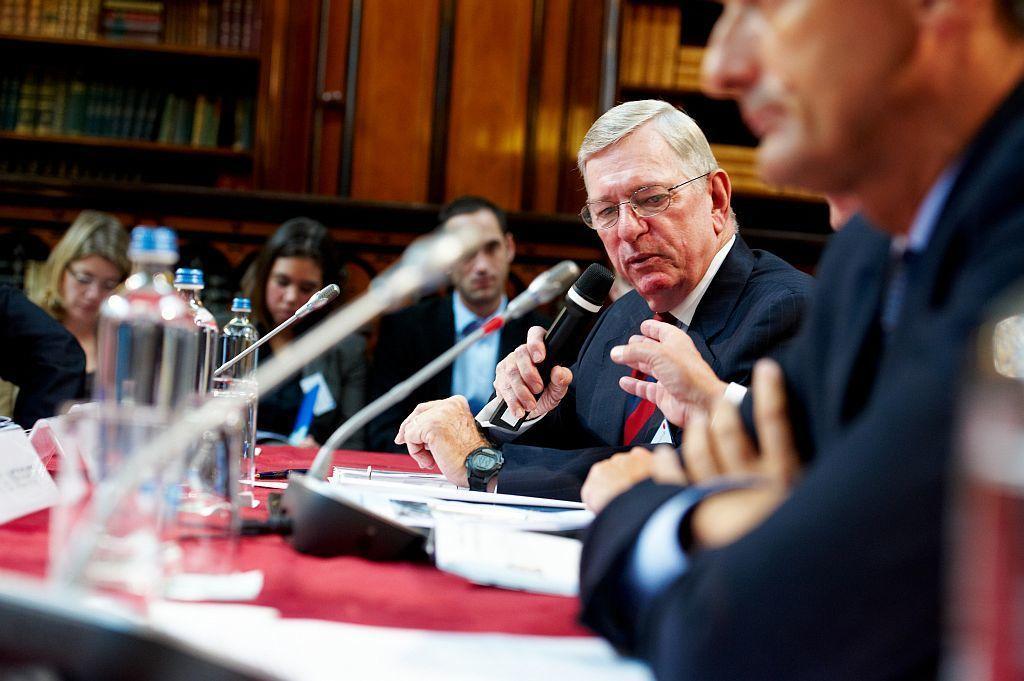Please provide a concise description of this image. In this image we can see some persons wearing suits sitting on chairs some are holding microphones, on right side of the image there are some water bottles, microphones, some name boards and some other objects and in the background of the image there are some books which are arranged in the shelves and there is a wooden surface. 